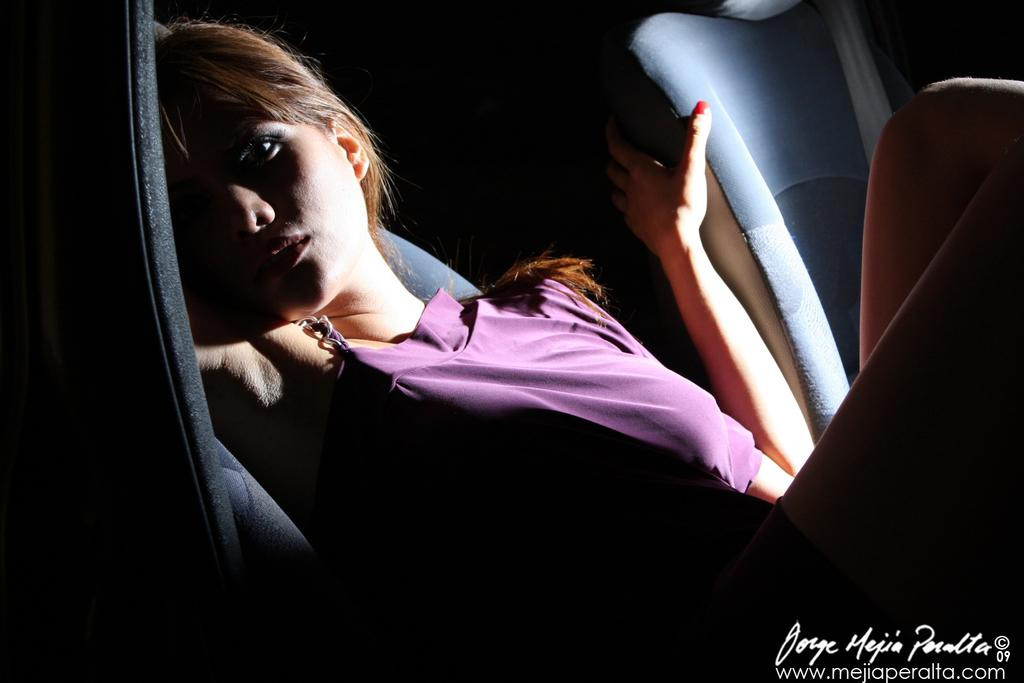Who is the main subject in the image? There is a woman in the image. What is the woman doing in the image? The woman is sitting on a seat. Are there any other seats visible in the image? Yes, there is another seat in the image. Can you describe any additional features of the image? There is a watermark in the image. How many quarters can be seen on the woman's seat in the image? There is no mention of quarters in the image, so it cannot be determined how many are present. 